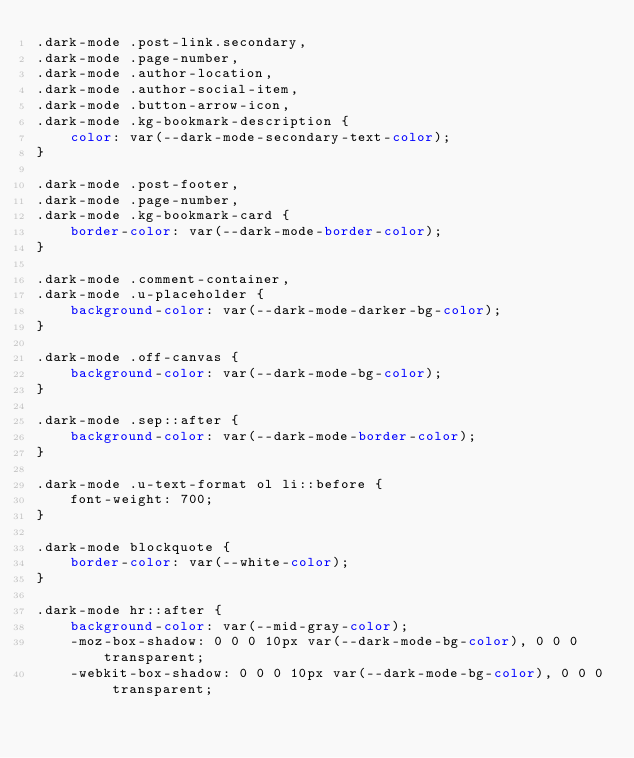<code> <loc_0><loc_0><loc_500><loc_500><_CSS_>.dark-mode .post-link.secondary,
.dark-mode .page-number,
.dark-mode .author-location,
.dark-mode .author-social-item,
.dark-mode .button-arrow-icon,
.dark-mode .kg-bookmark-description {
    color: var(--dark-mode-secondary-text-color);
}

.dark-mode .post-footer,
.dark-mode .page-number,
.dark-mode .kg-bookmark-card {
    border-color: var(--dark-mode-border-color);
}

.dark-mode .comment-container,
.dark-mode .u-placeholder {
    background-color: var(--dark-mode-darker-bg-color);
}

.dark-mode .off-canvas {
    background-color: var(--dark-mode-bg-color);
}

.dark-mode .sep::after {
    background-color: var(--dark-mode-border-color);
}

.dark-mode .u-text-format ol li::before {
    font-weight: 700;
}

.dark-mode blockquote {
    border-color: var(--white-color);
}

.dark-mode hr::after {
    background-color: var(--mid-gray-color);
    -moz-box-shadow: 0 0 0 10px var(--dark-mode-bg-color), 0 0 0 transparent;
    -webkit-box-shadow: 0 0 0 10px var(--dark-mode-bg-color), 0 0 0 transparent;</code> 